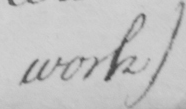Can you read and transcribe this handwriting? work ) 